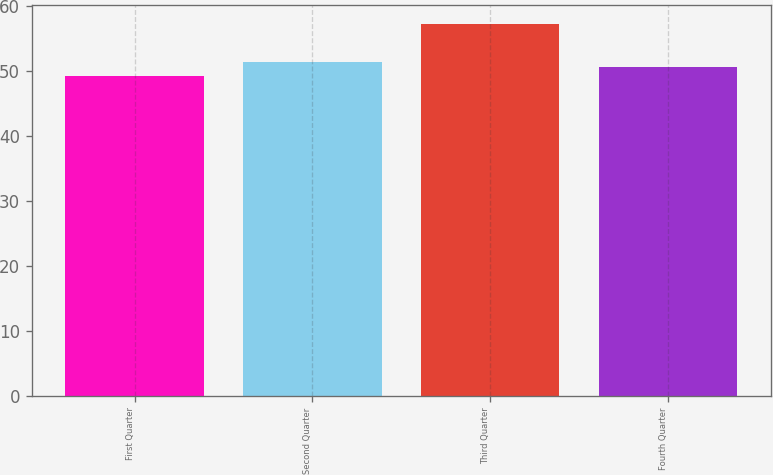Convert chart to OTSL. <chart><loc_0><loc_0><loc_500><loc_500><bar_chart><fcel>First Quarter<fcel>Second Quarter<fcel>Third Quarter<fcel>Fourth Quarter<nl><fcel>49.18<fcel>51.36<fcel>57.16<fcel>50.56<nl></chart> 